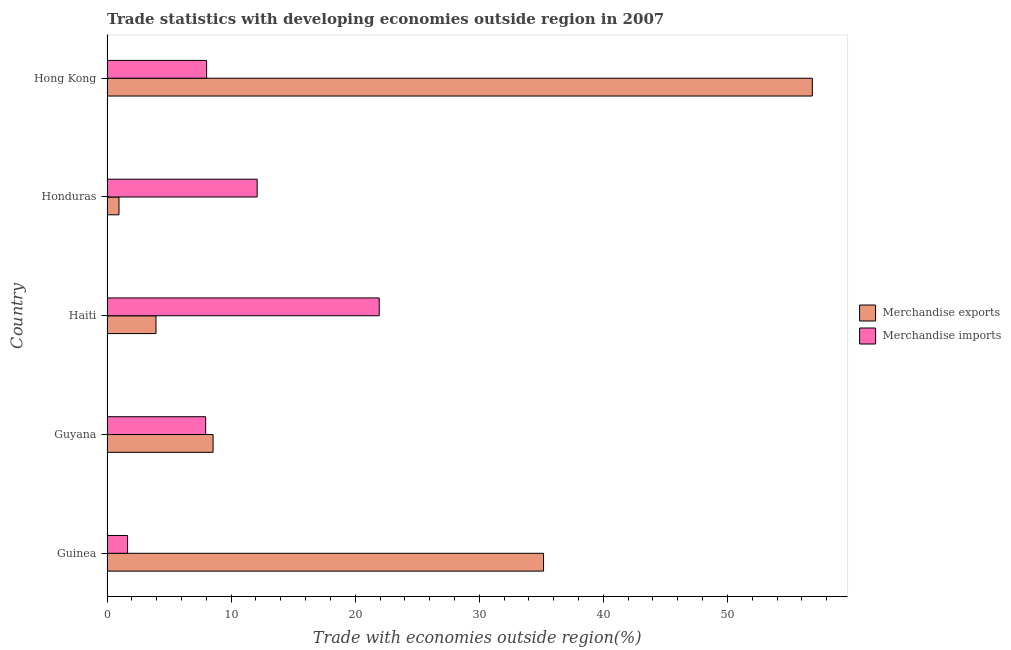How many bars are there on the 2nd tick from the top?
Make the answer very short. 2. How many bars are there on the 3rd tick from the bottom?
Make the answer very short. 2. What is the label of the 3rd group of bars from the top?
Your response must be concise. Haiti. What is the merchandise imports in Honduras?
Offer a very short reply. 12.1. Across all countries, what is the maximum merchandise exports?
Provide a short and direct response. 56.84. Across all countries, what is the minimum merchandise imports?
Your answer should be very brief. 1.66. In which country was the merchandise imports maximum?
Your response must be concise. Haiti. In which country was the merchandise exports minimum?
Give a very brief answer. Honduras. What is the total merchandise exports in the graph?
Offer a terse response. 105.48. What is the difference between the merchandise exports in Guinea and that in Guyana?
Offer a very short reply. 26.63. What is the difference between the merchandise exports in Guinea and the merchandise imports in Haiti?
Give a very brief answer. 13.24. What is the average merchandise imports per country?
Offer a terse response. 10.33. What is the difference between the merchandise imports and merchandise exports in Guyana?
Ensure brevity in your answer.  -0.6. Is the merchandise imports in Honduras less than that in Hong Kong?
Keep it short and to the point. No. What is the difference between the highest and the second highest merchandise imports?
Make the answer very short. 9.84. What is the difference between the highest and the lowest merchandise exports?
Offer a terse response. 55.87. In how many countries, is the merchandise imports greater than the average merchandise imports taken over all countries?
Your answer should be compact. 2. Is the sum of the merchandise exports in Guinea and Haiti greater than the maximum merchandise imports across all countries?
Your answer should be compact. Yes. What does the 2nd bar from the top in Guinea represents?
Your response must be concise. Merchandise exports. What does the 1st bar from the bottom in Guinea represents?
Keep it short and to the point. Merchandise exports. Does the graph contain any zero values?
Provide a succinct answer. No. Does the graph contain grids?
Provide a short and direct response. No. How many legend labels are there?
Your answer should be compact. 2. How are the legend labels stacked?
Give a very brief answer. Vertical. What is the title of the graph?
Provide a short and direct response. Trade statistics with developing economies outside region in 2007. Does "Techinal cooperation" appear as one of the legend labels in the graph?
Offer a terse response. No. What is the label or title of the X-axis?
Provide a short and direct response. Trade with economies outside region(%). What is the Trade with economies outside region(%) in Merchandise exports in Guinea?
Ensure brevity in your answer.  35.18. What is the Trade with economies outside region(%) of Merchandise imports in Guinea?
Your response must be concise. 1.66. What is the Trade with economies outside region(%) of Merchandise exports in Guyana?
Give a very brief answer. 8.55. What is the Trade with economies outside region(%) of Merchandise imports in Guyana?
Your answer should be very brief. 7.95. What is the Trade with economies outside region(%) in Merchandise exports in Haiti?
Your answer should be compact. 3.95. What is the Trade with economies outside region(%) of Merchandise imports in Haiti?
Offer a terse response. 21.94. What is the Trade with economies outside region(%) of Merchandise exports in Honduras?
Your answer should be compact. 0.97. What is the Trade with economies outside region(%) in Merchandise imports in Honduras?
Offer a terse response. 12.1. What is the Trade with economies outside region(%) of Merchandise exports in Hong Kong?
Ensure brevity in your answer.  56.84. What is the Trade with economies outside region(%) in Merchandise imports in Hong Kong?
Your answer should be very brief. 8.03. Across all countries, what is the maximum Trade with economies outside region(%) in Merchandise exports?
Provide a succinct answer. 56.84. Across all countries, what is the maximum Trade with economies outside region(%) of Merchandise imports?
Provide a succinct answer. 21.94. Across all countries, what is the minimum Trade with economies outside region(%) of Merchandise exports?
Keep it short and to the point. 0.97. Across all countries, what is the minimum Trade with economies outside region(%) in Merchandise imports?
Offer a very short reply. 1.66. What is the total Trade with economies outside region(%) in Merchandise exports in the graph?
Ensure brevity in your answer.  105.48. What is the total Trade with economies outside region(%) of Merchandise imports in the graph?
Make the answer very short. 51.67. What is the difference between the Trade with economies outside region(%) of Merchandise exports in Guinea and that in Guyana?
Provide a short and direct response. 26.63. What is the difference between the Trade with economies outside region(%) of Merchandise imports in Guinea and that in Guyana?
Your response must be concise. -6.29. What is the difference between the Trade with economies outside region(%) in Merchandise exports in Guinea and that in Haiti?
Offer a terse response. 31.23. What is the difference between the Trade with economies outside region(%) of Merchandise imports in Guinea and that in Haiti?
Offer a very short reply. -20.28. What is the difference between the Trade with economies outside region(%) in Merchandise exports in Guinea and that in Honduras?
Offer a terse response. 34.21. What is the difference between the Trade with economies outside region(%) in Merchandise imports in Guinea and that in Honduras?
Offer a terse response. -10.44. What is the difference between the Trade with economies outside region(%) in Merchandise exports in Guinea and that in Hong Kong?
Provide a succinct answer. -21.66. What is the difference between the Trade with economies outside region(%) of Merchandise imports in Guinea and that in Hong Kong?
Make the answer very short. -6.37. What is the difference between the Trade with economies outside region(%) in Merchandise exports in Guyana and that in Haiti?
Keep it short and to the point. 4.6. What is the difference between the Trade with economies outside region(%) in Merchandise imports in Guyana and that in Haiti?
Ensure brevity in your answer.  -13.99. What is the difference between the Trade with economies outside region(%) of Merchandise exports in Guyana and that in Honduras?
Provide a succinct answer. 7.58. What is the difference between the Trade with economies outside region(%) of Merchandise imports in Guyana and that in Honduras?
Offer a very short reply. -4.15. What is the difference between the Trade with economies outside region(%) of Merchandise exports in Guyana and that in Hong Kong?
Your answer should be compact. -48.29. What is the difference between the Trade with economies outside region(%) in Merchandise imports in Guyana and that in Hong Kong?
Your answer should be compact. -0.08. What is the difference between the Trade with economies outside region(%) in Merchandise exports in Haiti and that in Honduras?
Offer a terse response. 2.98. What is the difference between the Trade with economies outside region(%) of Merchandise imports in Haiti and that in Honduras?
Provide a short and direct response. 9.84. What is the difference between the Trade with economies outside region(%) of Merchandise exports in Haiti and that in Hong Kong?
Your answer should be very brief. -52.89. What is the difference between the Trade with economies outside region(%) in Merchandise imports in Haiti and that in Hong Kong?
Ensure brevity in your answer.  13.91. What is the difference between the Trade with economies outside region(%) in Merchandise exports in Honduras and that in Hong Kong?
Your answer should be compact. -55.87. What is the difference between the Trade with economies outside region(%) in Merchandise imports in Honduras and that in Hong Kong?
Make the answer very short. 4.07. What is the difference between the Trade with economies outside region(%) of Merchandise exports in Guinea and the Trade with economies outside region(%) of Merchandise imports in Guyana?
Offer a terse response. 27.23. What is the difference between the Trade with economies outside region(%) of Merchandise exports in Guinea and the Trade with economies outside region(%) of Merchandise imports in Haiti?
Your answer should be very brief. 13.24. What is the difference between the Trade with economies outside region(%) of Merchandise exports in Guinea and the Trade with economies outside region(%) of Merchandise imports in Honduras?
Keep it short and to the point. 23.08. What is the difference between the Trade with economies outside region(%) in Merchandise exports in Guinea and the Trade with economies outside region(%) in Merchandise imports in Hong Kong?
Provide a short and direct response. 27.15. What is the difference between the Trade with economies outside region(%) of Merchandise exports in Guyana and the Trade with economies outside region(%) of Merchandise imports in Haiti?
Your answer should be compact. -13.39. What is the difference between the Trade with economies outside region(%) of Merchandise exports in Guyana and the Trade with economies outside region(%) of Merchandise imports in Honduras?
Provide a succinct answer. -3.55. What is the difference between the Trade with economies outside region(%) of Merchandise exports in Guyana and the Trade with economies outside region(%) of Merchandise imports in Hong Kong?
Provide a short and direct response. 0.52. What is the difference between the Trade with economies outside region(%) in Merchandise exports in Haiti and the Trade with economies outside region(%) in Merchandise imports in Honduras?
Offer a very short reply. -8.15. What is the difference between the Trade with economies outside region(%) in Merchandise exports in Haiti and the Trade with economies outside region(%) in Merchandise imports in Hong Kong?
Ensure brevity in your answer.  -4.08. What is the difference between the Trade with economies outside region(%) in Merchandise exports in Honduras and the Trade with economies outside region(%) in Merchandise imports in Hong Kong?
Your response must be concise. -7.06. What is the average Trade with economies outside region(%) in Merchandise exports per country?
Offer a very short reply. 21.1. What is the average Trade with economies outside region(%) of Merchandise imports per country?
Your answer should be compact. 10.33. What is the difference between the Trade with economies outside region(%) of Merchandise exports and Trade with economies outside region(%) of Merchandise imports in Guinea?
Your answer should be compact. 33.52. What is the difference between the Trade with economies outside region(%) in Merchandise exports and Trade with economies outside region(%) in Merchandise imports in Guyana?
Give a very brief answer. 0.6. What is the difference between the Trade with economies outside region(%) of Merchandise exports and Trade with economies outside region(%) of Merchandise imports in Haiti?
Ensure brevity in your answer.  -17.99. What is the difference between the Trade with economies outside region(%) of Merchandise exports and Trade with economies outside region(%) of Merchandise imports in Honduras?
Your answer should be compact. -11.13. What is the difference between the Trade with economies outside region(%) in Merchandise exports and Trade with economies outside region(%) in Merchandise imports in Hong Kong?
Your answer should be compact. 48.81. What is the ratio of the Trade with economies outside region(%) in Merchandise exports in Guinea to that in Guyana?
Provide a succinct answer. 4.12. What is the ratio of the Trade with economies outside region(%) of Merchandise imports in Guinea to that in Guyana?
Make the answer very short. 0.21. What is the ratio of the Trade with economies outside region(%) of Merchandise exports in Guinea to that in Haiti?
Your answer should be very brief. 8.91. What is the ratio of the Trade with economies outside region(%) in Merchandise imports in Guinea to that in Haiti?
Give a very brief answer. 0.08. What is the ratio of the Trade with economies outside region(%) in Merchandise exports in Guinea to that in Honduras?
Your answer should be compact. 36.37. What is the ratio of the Trade with economies outside region(%) in Merchandise imports in Guinea to that in Honduras?
Your answer should be very brief. 0.14. What is the ratio of the Trade with economies outside region(%) of Merchandise exports in Guinea to that in Hong Kong?
Provide a succinct answer. 0.62. What is the ratio of the Trade with economies outside region(%) of Merchandise imports in Guinea to that in Hong Kong?
Provide a short and direct response. 0.21. What is the ratio of the Trade with economies outside region(%) in Merchandise exports in Guyana to that in Haiti?
Your response must be concise. 2.16. What is the ratio of the Trade with economies outside region(%) in Merchandise imports in Guyana to that in Haiti?
Your answer should be very brief. 0.36. What is the ratio of the Trade with economies outside region(%) of Merchandise exports in Guyana to that in Honduras?
Your answer should be very brief. 8.84. What is the ratio of the Trade with economies outside region(%) of Merchandise imports in Guyana to that in Honduras?
Make the answer very short. 0.66. What is the ratio of the Trade with economies outside region(%) in Merchandise exports in Guyana to that in Hong Kong?
Offer a very short reply. 0.15. What is the ratio of the Trade with economies outside region(%) in Merchandise exports in Haiti to that in Honduras?
Ensure brevity in your answer.  4.08. What is the ratio of the Trade with economies outside region(%) of Merchandise imports in Haiti to that in Honduras?
Your response must be concise. 1.81. What is the ratio of the Trade with economies outside region(%) in Merchandise exports in Haiti to that in Hong Kong?
Ensure brevity in your answer.  0.07. What is the ratio of the Trade with economies outside region(%) of Merchandise imports in Haiti to that in Hong Kong?
Offer a terse response. 2.73. What is the ratio of the Trade with economies outside region(%) in Merchandise exports in Honduras to that in Hong Kong?
Ensure brevity in your answer.  0.02. What is the ratio of the Trade with economies outside region(%) in Merchandise imports in Honduras to that in Hong Kong?
Your answer should be very brief. 1.51. What is the difference between the highest and the second highest Trade with economies outside region(%) of Merchandise exports?
Your answer should be very brief. 21.66. What is the difference between the highest and the second highest Trade with economies outside region(%) of Merchandise imports?
Ensure brevity in your answer.  9.84. What is the difference between the highest and the lowest Trade with economies outside region(%) of Merchandise exports?
Your answer should be compact. 55.87. What is the difference between the highest and the lowest Trade with economies outside region(%) in Merchandise imports?
Make the answer very short. 20.28. 